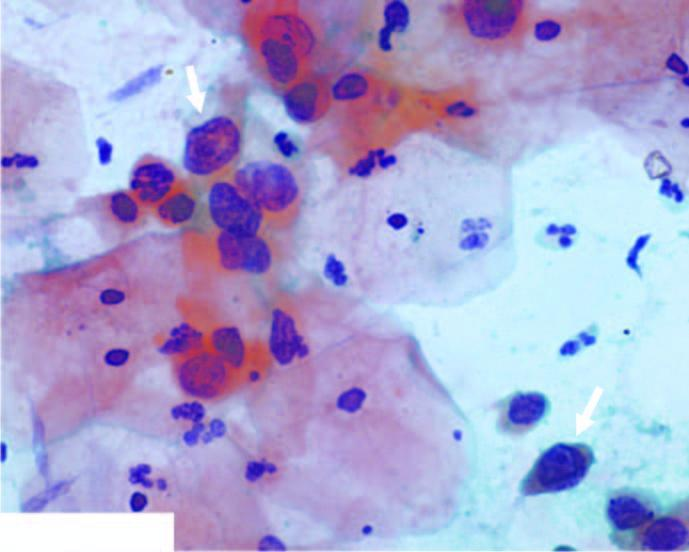what have irregular nuclear outlines?
Answer the question using a single word or phrase. The squamous cells have scanty cytoplasm and markedly hyperchromatic nuclei 